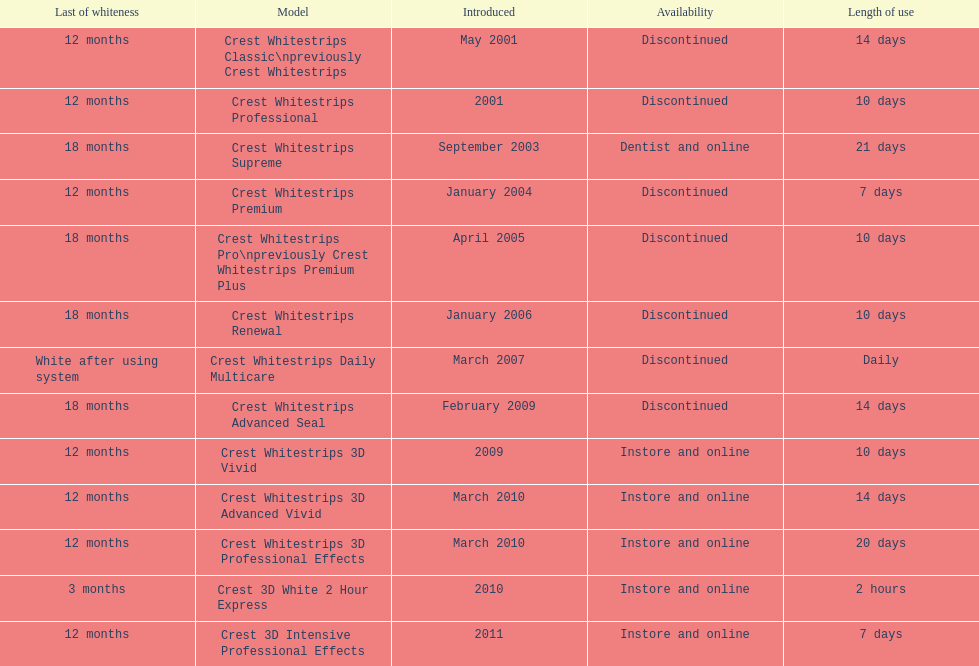Does the crest white strips pro last as long as the crest white strips renewal? Yes. 